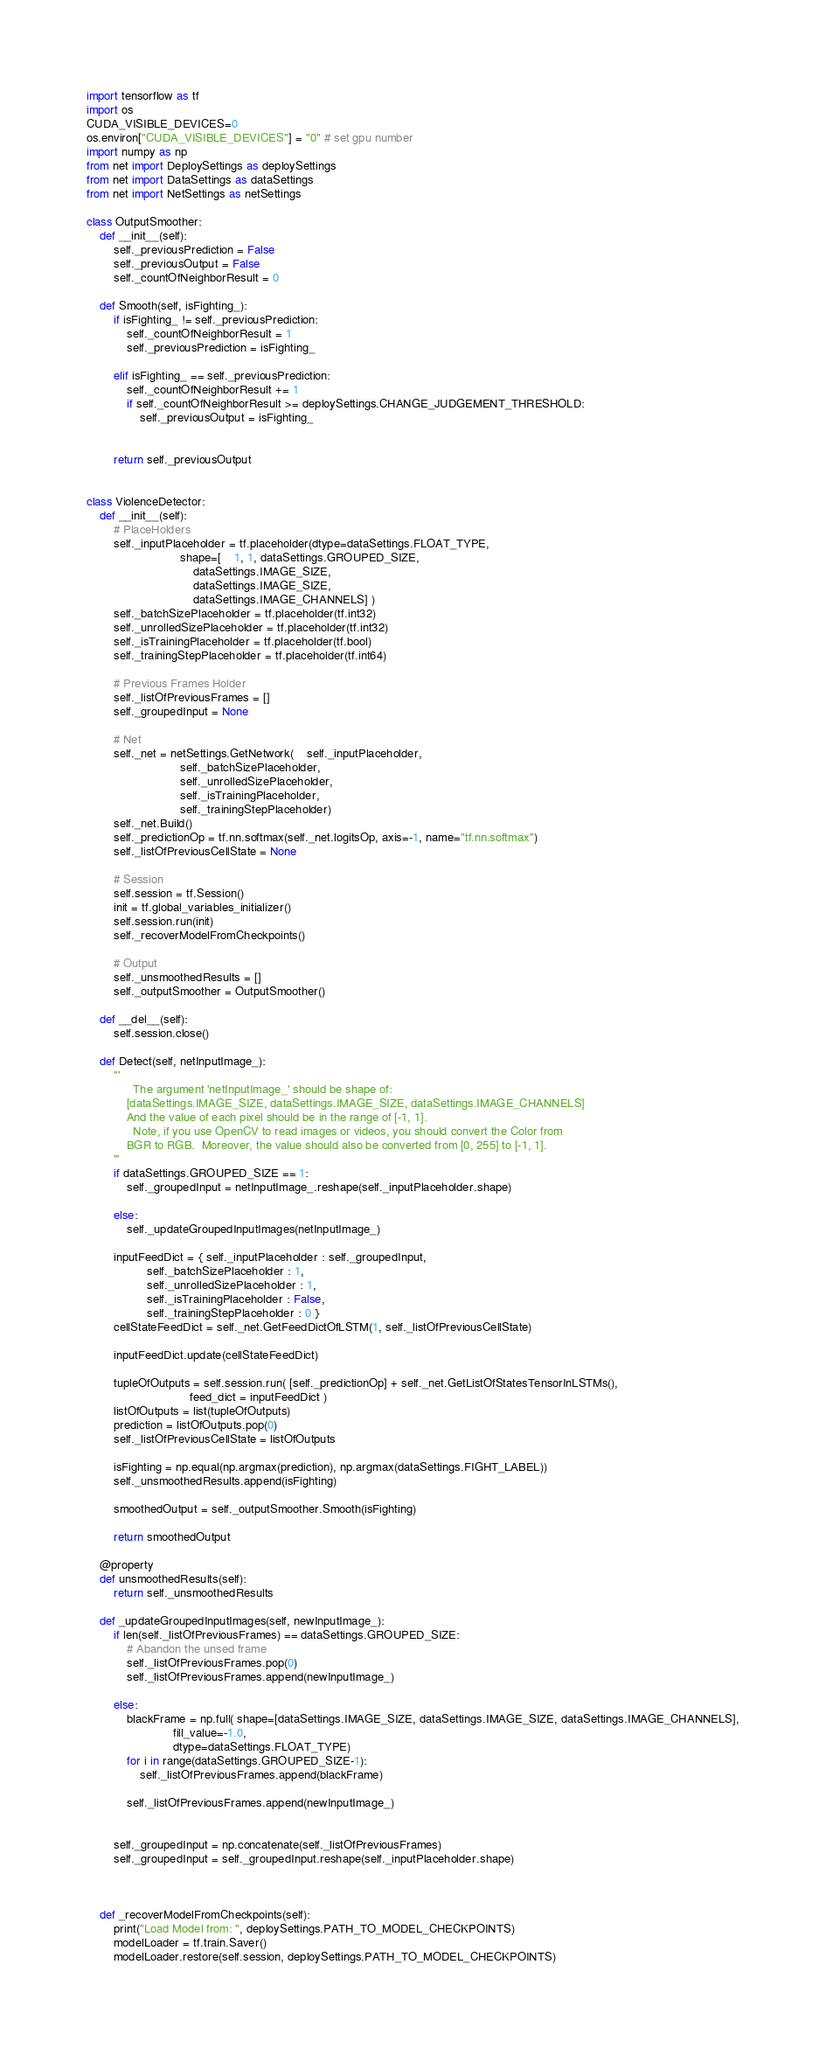Convert code to text. <code><loc_0><loc_0><loc_500><loc_500><_Python_>import tensorflow as tf
import os
CUDA_VISIBLE_DEVICES=0
os.environ["CUDA_VISIBLE_DEVICES"] = "0" # set gpu number
import numpy as np
from net import DeploySettings as deploySettings
from net import DataSettings as dataSettings
from net import NetSettings as netSettings

class OutputSmoother:
	def __init__(self):
		self._previousPrediction = False
		self._previousOutput = False
		self._countOfNeighborResult = 0

	def Smooth(self, isFighting_):
		if isFighting_ != self._previousPrediction:
			self._countOfNeighborResult = 1
			self._previousPrediction = isFighting_

		elif isFighting_ == self._previousPrediction:
			self._countOfNeighborResult += 1
			if self._countOfNeighborResult >= deploySettings.CHANGE_JUDGEMENT_THRESHOLD:
				self._previousOutput = isFighting_
			

		return self._previousOutput


class ViolenceDetector:
	def __init__(self):
		# PlaceHolders
		self._inputPlaceholder = tf.placeholder(dtype=dataSettings.FLOAT_TYPE,
							shape=[	1, 1, dataSettings.GROUPED_SIZE,
								dataSettings.IMAGE_SIZE,
								dataSettings.IMAGE_SIZE,
								dataSettings.IMAGE_CHANNELS] )
		self._batchSizePlaceholder = tf.placeholder(tf.int32)
		self._unrolledSizePlaceholder = tf.placeholder(tf.int32)
		self._isTrainingPlaceholder = tf.placeholder(tf.bool)
		self._trainingStepPlaceholder = tf.placeholder(tf.int64)

		# Previous Frames Holder
		self._listOfPreviousFrames = []
		self._groupedInput = None

		# Net
		self._net = netSettings.GetNetwork(	self._inputPlaceholder,
							self._batchSizePlaceholder,
							self._unrolledSizePlaceholder,
							self._isTrainingPlaceholder,
							self._trainingStepPlaceholder)
		self._net.Build()
		self._predictionOp = tf.nn.softmax(self._net.logitsOp, axis=-1, name="tf.nn.softmax")
		self._listOfPreviousCellState = None

		# Session
		self.session = tf.Session()
		init = tf.global_variables_initializer()
		self.session.run(init)
		self._recoverModelFromCheckpoints()

		# Output
		self._unsmoothedResults = []
		self._outputSmoother = OutputSmoother()

	def __del__(self):
		self.session.close()

	def Detect(self, netInputImage_):
		'''
		      The argument 'netInputImage_' should be shape of:
		    [dataSettings.IMAGE_SIZE, dataSettings.IMAGE_SIZE, dataSettings.IMAGE_CHANNELS]
		    And the value of each pixel should be in the range of [-1, 1].
		      Note, if you use OpenCV to read images or videos, you should convert the Color from
		    BGR to RGB.  Moreover, the value should also be converted from [0, 255] to [-1, 1].
		'''
		if dataSettings.GROUPED_SIZE == 1:
			self._groupedInput = netInputImage_.reshape(self._inputPlaceholder.shape)

		else:
			self._updateGroupedInputImages(netInputImage_)

		inputFeedDict = { self._inputPlaceholder : self._groupedInput,
				  self._batchSizePlaceholder : 1,
				  self._unrolledSizePlaceholder : 1,
				  self._isTrainingPlaceholder : False,
				  self._trainingStepPlaceholder : 0 }
		cellStateFeedDict = self._net.GetFeedDictOfLSTM(1, self._listOfPreviousCellState)

		inputFeedDict.update(cellStateFeedDict)

		tupleOfOutputs = self.session.run( [self._predictionOp] + self._net.GetListOfStatesTensorInLSTMs(),
			     			   feed_dict = inputFeedDict )
		listOfOutputs = list(tupleOfOutputs)
		prediction = listOfOutputs.pop(0)
		self._listOfPreviousCellState = listOfOutputs

		isFighting = np.equal(np.argmax(prediction), np.argmax(dataSettings.FIGHT_LABEL))
		self._unsmoothedResults.append(isFighting)

		smoothedOutput = self._outputSmoother.Smooth(isFighting)

		return smoothedOutput

	@property
	def unsmoothedResults(self):
		return self._unsmoothedResults

	def _updateGroupedInputImages(self, newInputImage_):
		if len(self._listOfPreviousFrames) == dataSettings.GROUPED_SIZE:
			# Abandon the unsed frame
			self._listOfPreviousFrames.pop(0)
			self._listOfPreviousFrames.append(newInputImage_)

		else:
			blackFrame = np.full( shape=[dataSettings.IMAGE_SIZE, dataSettings.IMAGE_SIZE, dataSettings.IMAGE_CHANNELS],
					      fill_value=-1.0,
					      dtype=dataSettings.FLOAT_TYPE)
			for i in range(dataSettings.GROUPED_SIZE-1):
				self._listOfPreviousFrames.append(blackFrame)

			self._listOfPreviousFrames.append(newInputImage_)


		self._groupedInput = np.concatenate(self._listOfPreviousFrames)
		self._groupedInput = self._groupedInput.reshape(self._inputPlaceholder.shape)
			
			

	def _recoverModelFromCheckpoints(self):
		print("Load Model from: ", deploySettings.PATH_TO_MODEL_CHECKPOINTS)
		modelLoader = tf.train.Saver()
		modelLoader.restore(self.session, deploySettings.PATH_TO_MODEL_CHECKPOINTS)


</code> 